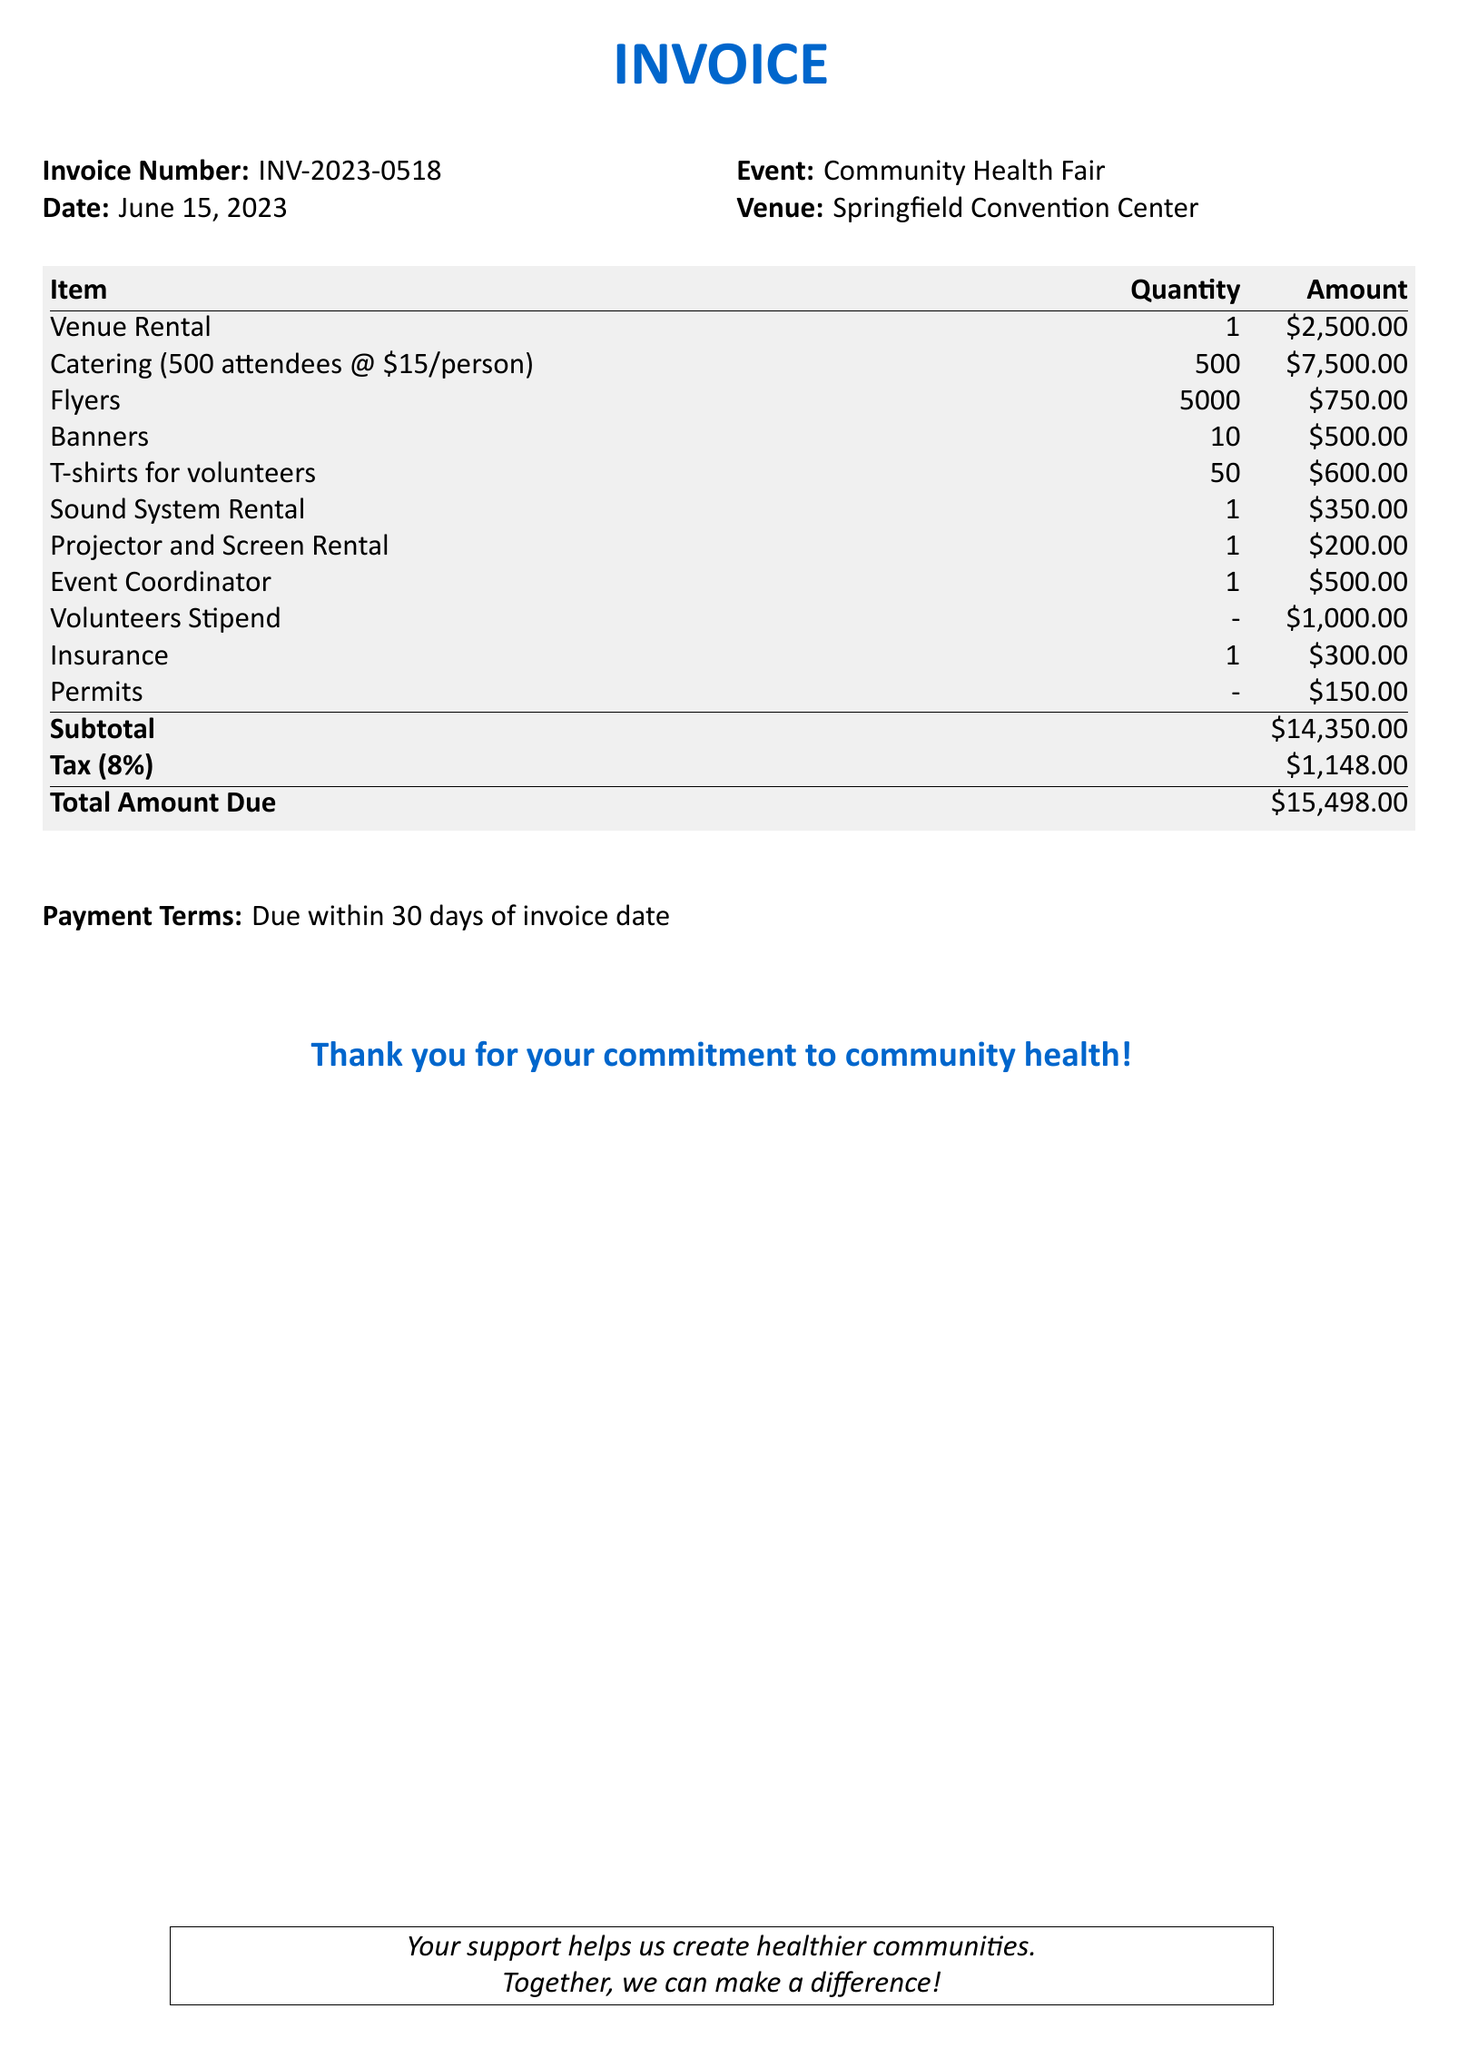what is the invoice number? The invoice number is clearly stated in the document for reference and tracking, which is INV-2023-0518.
Answer: INV-2023-0518 what is the total amount due? The total amount due is calculated as the subtotal plus tax, which is stated in the document as $15,498.00.
Answer: $15,498.00 how many attendees were catered for? The number of attendees catered for is listed in the catering item description, which is 500.
Answer: 500 what is the venue for the event? The venue for the event is specified in the document, indicating it will take place at the Springfield Convention Center.
Answer: Springfield Convention Center how much is the venue rental cost? The venue rental cost is specified as a single item on the invoice, which is $2,500.00.
Answer: $2,500.00 what percentage is the tax? The tax percentage applied to the subtotal is mentioned in the document, which is 8%.
Answer: 8% how many banners were ordered? The quantity of banners ordered is listed in the invoice item, which states there are 10 banners.
Answer: 10 what is the payment term duration? The payment terms are stated in the invoice, mentioning that payment is due within 30 days of the invoice date.
Answer: 30 days what is the subtotal amount before tax? The subtotal amount before tax is a key figure listed in the invoice, which is $14,350.00.
Answer: $14,350.00 